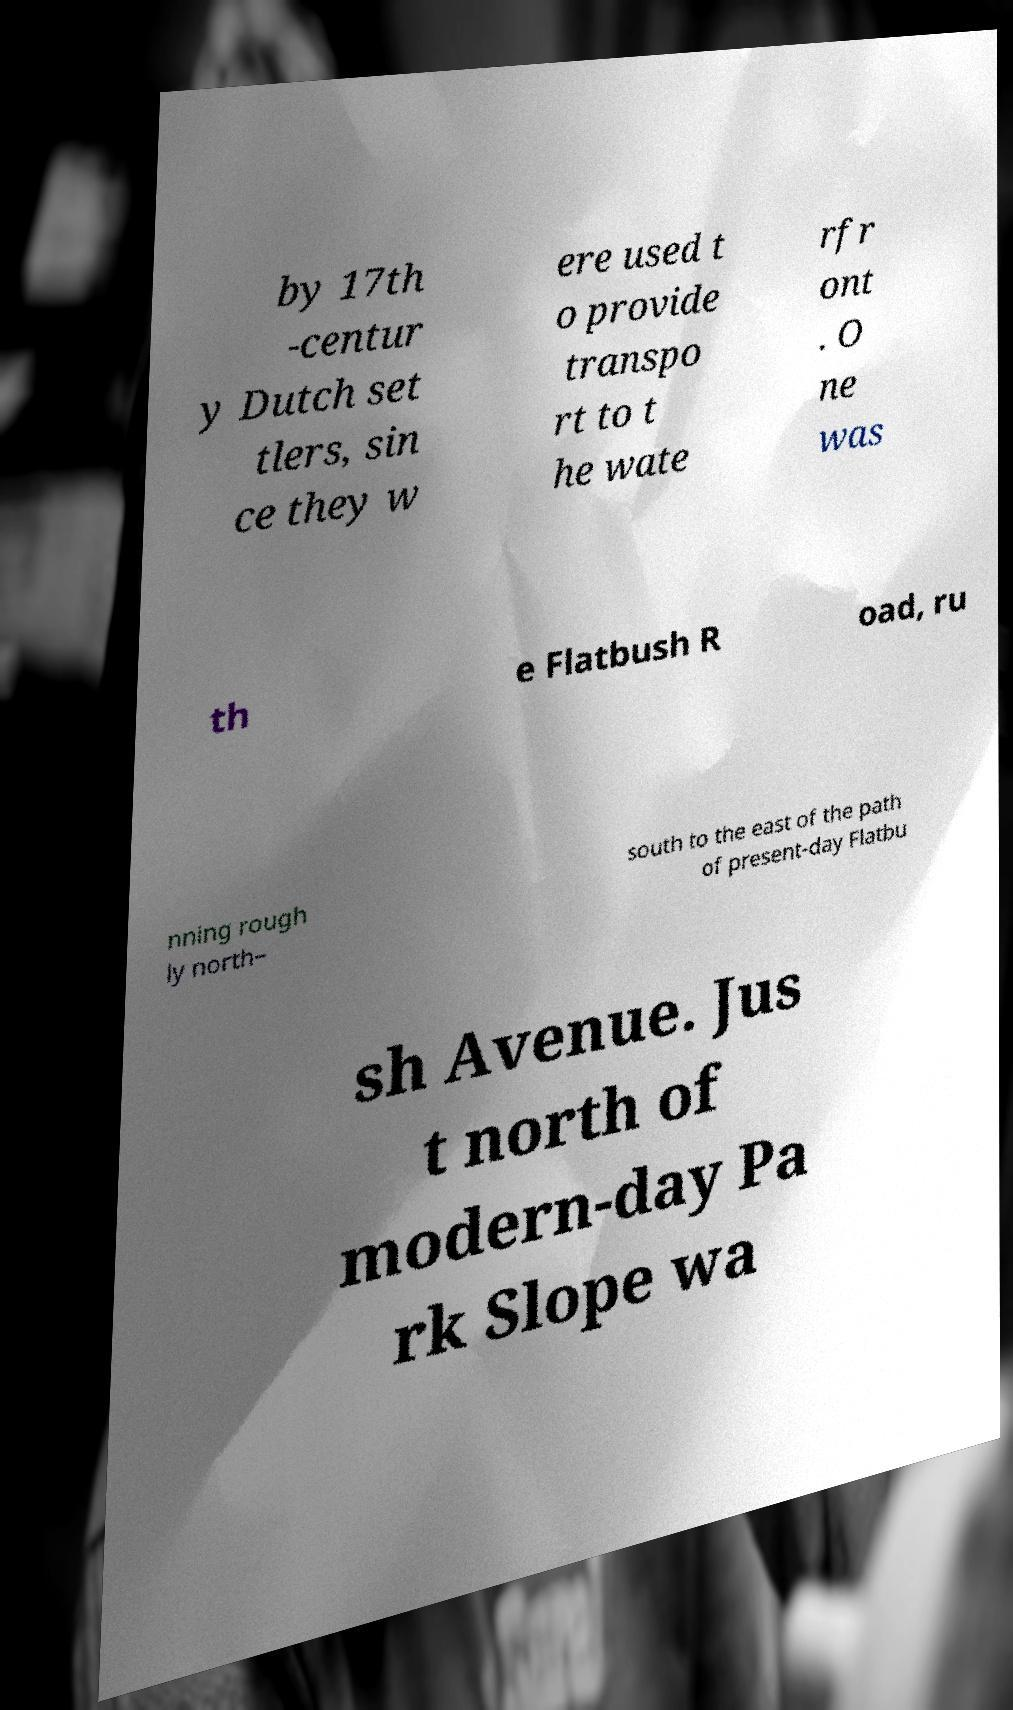Can you accurately transcribe the text from the provided image for me? by 17th -centur y Dutch set tlers, sin ce they w ere used t o provide transpo rt to t he wate rfr ont . O ne was th e Flatbush R oad, ru nning rough ly north– south to the east of the path of present-day Flatbu sh Avenue. Jus t north of modern-day Pa rk Slope wa 